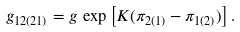Convert formula to latex. <formula><loc_0><loc_0><loc_500><loc_500>g _ { 1 2 ( 2 1 ) } = g \, \exp \left [ K ( \pi _ { 2 ( 1 ) } - \pi _ { 1 ( 2 ) } ) \right ] .</formula> 